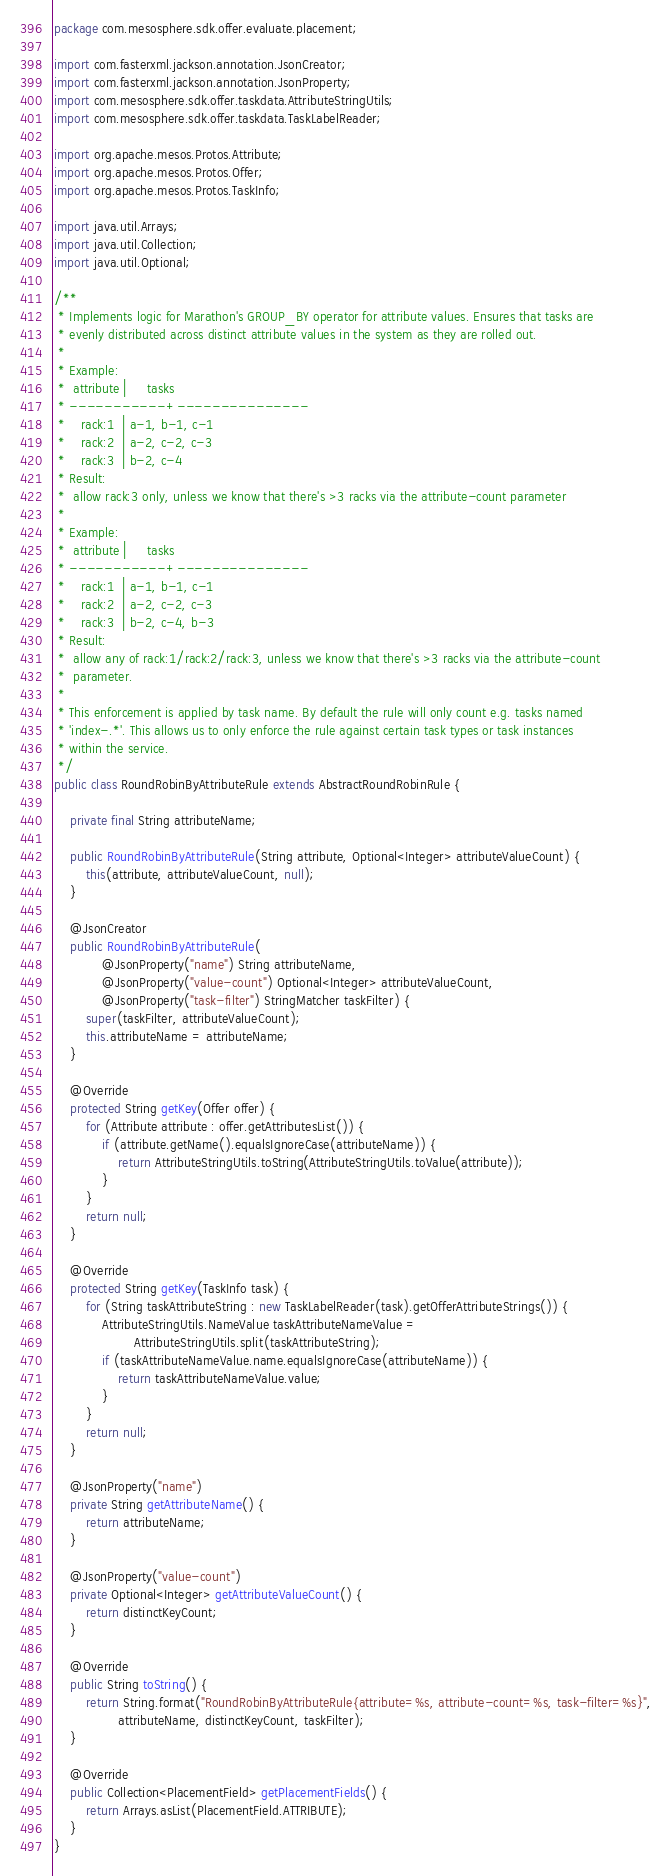<code> <loc_0><loc_0><loc_500><loc_500><_Java_>package com.mesosphere.sdk.offer.evaluate.placement;

import com.fasterxml.jackson.annotation.JsonCreator;
import com.fasterxml.jackson.annotation.JsonProperty;
import com.mesosphere.sdk.offer.taskdata.AttributeStringUtils;
import com.mesosphere.sdk.offer.taskdata.TaskLabelReader;

import org.apache.mesos.Protos.Attribute;
import org.apache.mesos.Protos.Offer;
import org.apache.mesos.Protos.TaskInfo;

import java.util.Arrays;
import java.util.Collection;
import java.util.Optional;

/**
 * Implements logic for Marathon's GROUP_BY operator for attribute values. Ensures that tasks are
 * evenly distributed across distinct attribute values in the system as they are rolled out.
 *
 * Example:
 *  attribute |     tasks
 * -----------+---------------
 *    rack:1  | a-1, b-1, c-1
 *    rack:2  | a-2, c-2, c-3
 *    rack:3  | b-2, c-4
 * Result:
 *  allow rack:3 only, unless we know that there's >3 racks via the attribute-count parameter
 *
 * Example:
 *  attribute |     tasks
 * -----------+---------------
 *    rack:1  | a-1, b-1, c-1
 *    rack:2  | a-2, c-2, c-3
 *    rack:3  | b-2, c-4, b-3
 * Result:
 *  allow any of rack:1/rack:2/rack:3, unless we know that there's >3 racks via the attribute-count
 *  parameter.
 *
 * This enforcement is applied by task name. By default the rule will only count e.g. tasks named
 * 'index-.*'. This allows us to only enforce the rule against certain task types or task instances
 * within the service.
 */
public class RoundRobinByAttributeRule extends AbstractRoundRobinRule {

    private final String attributeName;

    public RoundRobinByAttributeRule(String attribute, Optional<Integer> attributeValueCount) {
        this(attribute, attributeValueCount, null);
    }

    @JsonCreator
    public RoundRobinByAttributeRule(
            @JsonProperty("name") String attributeName,
            @JsonProperty("value-count") Optional<Integer> attributeValueCount,
            @JsonProperty("task-filter") StringMatcher taskFilter) {
        super(taskFilter, attributeValueCount);
        this.attributeName = attributeName;
    }

    @Override
    protected String getKey(Offer offer) {
        for (Attribute attribute : offer.getAttributesList()) {
            if (attribute.getName().equalsIgnoreCase(attributeName)) {
                return AttributeStringUtils.toString(AttributeStringUtils.toValue(attribute));
            }
        }
        return null;
    }

    @Override
    protected String getKey(TaskInfo task) {
        for (String taskAttributeString : new TaskLabelReader(task).getOfferAttributeStrings()) {
            AttributeStringUtils.NameValue taskAttributeNameValue =
                    AttributeStringUtils.split(taskAttributeString);
            if (taskAttributeNameValue.name.equalsIgnoreCase(attributeName)) {
                return taskAttributeNameValue.value;
            }
        }
        return null;
    }

    @JsonProperty("name")
    private String getAttributeName() {
        return attributeName;
    }

    @JsonProperty("value-count")
    private Optional<Integer> getAttributeValueCount() {
        return distinctKeyCount;
    }

    @Override
    public String toString() {
        return String.format("RoundRobinByAttributeRule{attribute=%s, attribute-count=%s, task-filter=%s}",
                attributeName, distinctKeyCount, taskFilter);
    }

    @Override
    public Collection<PlacementField> getPlacementFields() {
        return Arrays.asList(PlacementField.ATTRIBUTE);
    }
}
</code> 